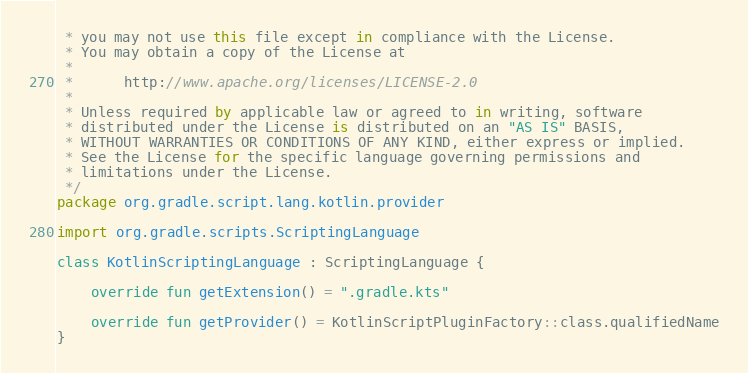<code> <loc_0><loc_0><loc_500><loc_500><_Kotlin_> * you may not use this file except in compliance with the License.
 * You may obtain a copy of the License at
 *
 *      http://www.apache.org/licenses/LICENSE-2.0
 *
 * Unless required by applicable law or agreed to in writing, software
 * distributed under the License is distributed on an "AS IS" BASIS,
 * WITHOUT WARRANTIES OR CONDITIONS OF ANY KIND, either express or implied.
 * See the License for the specific language governing permissions and
 * limitations under the License.
 */
package org.gradle.script.lang.kotlin.provider

import org.gradle.scripts.ScriptingLanguage

class KotlinScriptingLanguage : ScriptingLanguage {

    override fun getExtension() = ".gradle.kts"

    override fun getProvider() = KotlinScriptPluginFactory::class.qualifiedName
}
</code> 